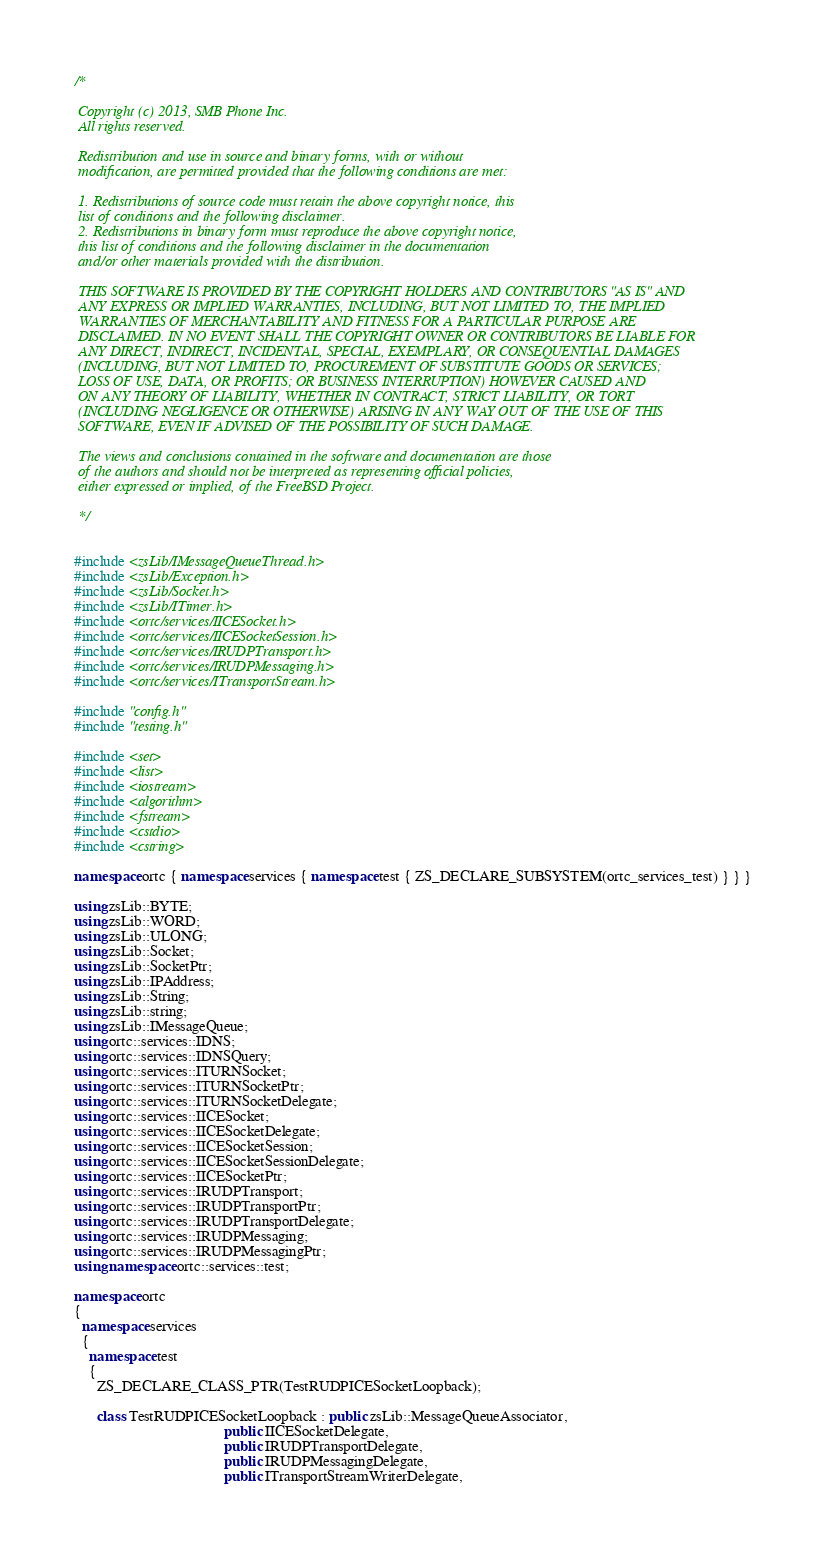Convert code to text. <code><loc_0><loc_0><loc_500><loc_500><_C++_>/*
 
 Copyright (c) 2013, SMB Phone Inc.
 All rights reserved.
 
 Redistribution and use in source and binary forms, with or without
 modification, are permitted provided that the following conditions are met:
 
 1. Redistributions of source code must retain the above copyright notice, this
 list of conditions and the following disclaimer.
 2. Redistributions in binary form must reproduce the above copyright notice,
 this list of conditions and the following disclaimer in the documentation
 and/or other materials provided with the distribution.
 
 THIS SOFTWARE IS PROVIDED BY THE COPYRIGHT HOLDERS AND CONTRIBUTORS "AS IS" AND
 ANY EXPRESS OR IMPLIED WARRANTIES, INCLUDING, BUT NOT LIMITED TO, THE IMPLIED
 WARRANTIES OF MERCHANTABILITY AND FITNESS FOR A PARTICULAR PURPOSE ARE
 DISCLAIMED. IN NO EVENT SHALL THE COPYRIGHT OWNER OR CONTRIBUTORS BE LIABLE FOR
 ANY DIRECT, INDIRECT, INCIDENTAL, SPECIAL, EXEMPLARY, OR CONSEQUENTIAL DAMAGES
 (INCLUDING, BUT NOT LIMITED TO, PROCUREMENT OF SUBSTITUTE GOODS OR SERVICES;
 LOSS OF USE, DATA, OR PROFITS; OR BUSINESS INTERRUPTION) HOWEVER CAUSED AND
 ON ANY THEORY OF LIABILITY, WHETHER IN CONTRACT, STRICT LIABILITY, OR TORT
 (INCLUDING NEGLIGENCE OR OTHERWISE) ARISING IN ANY WAY OUT OF THE USE OF THIS
 SOFTWARE, EVEN IF ADVISED OF THE POSSIBILITY OF SUCH DAMAGE.
 
 The views and conclusions contained in the software and documentation are those
 of the authors and should not be interpreted as representing official policies,
 either expressed or implied, of the FreeBSD Project.
 
 */


#include <zsLib/IMessageQueueThread.h>
#include <zsLib/Exception.h>
#include <zsLib/Socket.h>
#include <zsLib/ITimer.h>
#include <ortc/services/IICESocket.h>
#include <ortc/services/IICESocketSession.h>
#include <ortc/services/IRUDPTransport.h>
#include <ortc/services/IRUDPMessaging.h>
#include <ortc/services/ITransportStream.h>

#include "config.h"
#include "testing.h"

#include <set>
#include <list>
#include <iostream>
#include <algorithm>
#include <fstream>
#include <cstdio>
#include <cstring>

namespace ortc { namespace services { namespace test { ZS_DECLARE_SUBSYSTEM(ortc_services_test) } } }

using zsLib::BYTE;
using zsLib::WORD;
using zsLib::ULONG;
using zsLib::Socket;
using zsLib::SocketPtr;
using zsLib::IPAddress;
using zsLib::String;
using zsLib::string;
using zsLib::IMessageQueue;
using ortc::services::IDNS;
using ortc::services::IDNSQuery;
using ortc::services::ITURNSocket;
using ortc::services::ITURNSocketPtr;
using ortc::services::ITURNSocketDelegate;
using ortc::services::IICESocket;
using ortc::services::IICESocketDelegate;
using ortc::services::IICESocketSession;
using ortc::services::IICESocketSessionDelegate;
using ortc::services::IICESocketPtr;
using ortc::services::IRUDPTransport;
using ortc::services::IRUDPTransportPtr;
using ortc::services::IRUDPTransportDelegate;
using ortc::services::IRUDPMessaging;
using ortc::services::IRUDPMessagingPtr;
using namespace ortc::services::test;

namespace ortc
{
  namespace services
  {
    namespace test
    {
      ZS_DECLARE_CLASS_PTR(TestRUDPICESocketLoopback);

      class TestRUDPICESocketLoopback : public zsLib::MessageQueueAssociator,
                                        public IICESocketDelegate,
                                        public IRUDPTransportDelegate,
                                        public IRUDPMessagingDelegate,
                                        public ITransportStreamWriterDelegate,</code> 